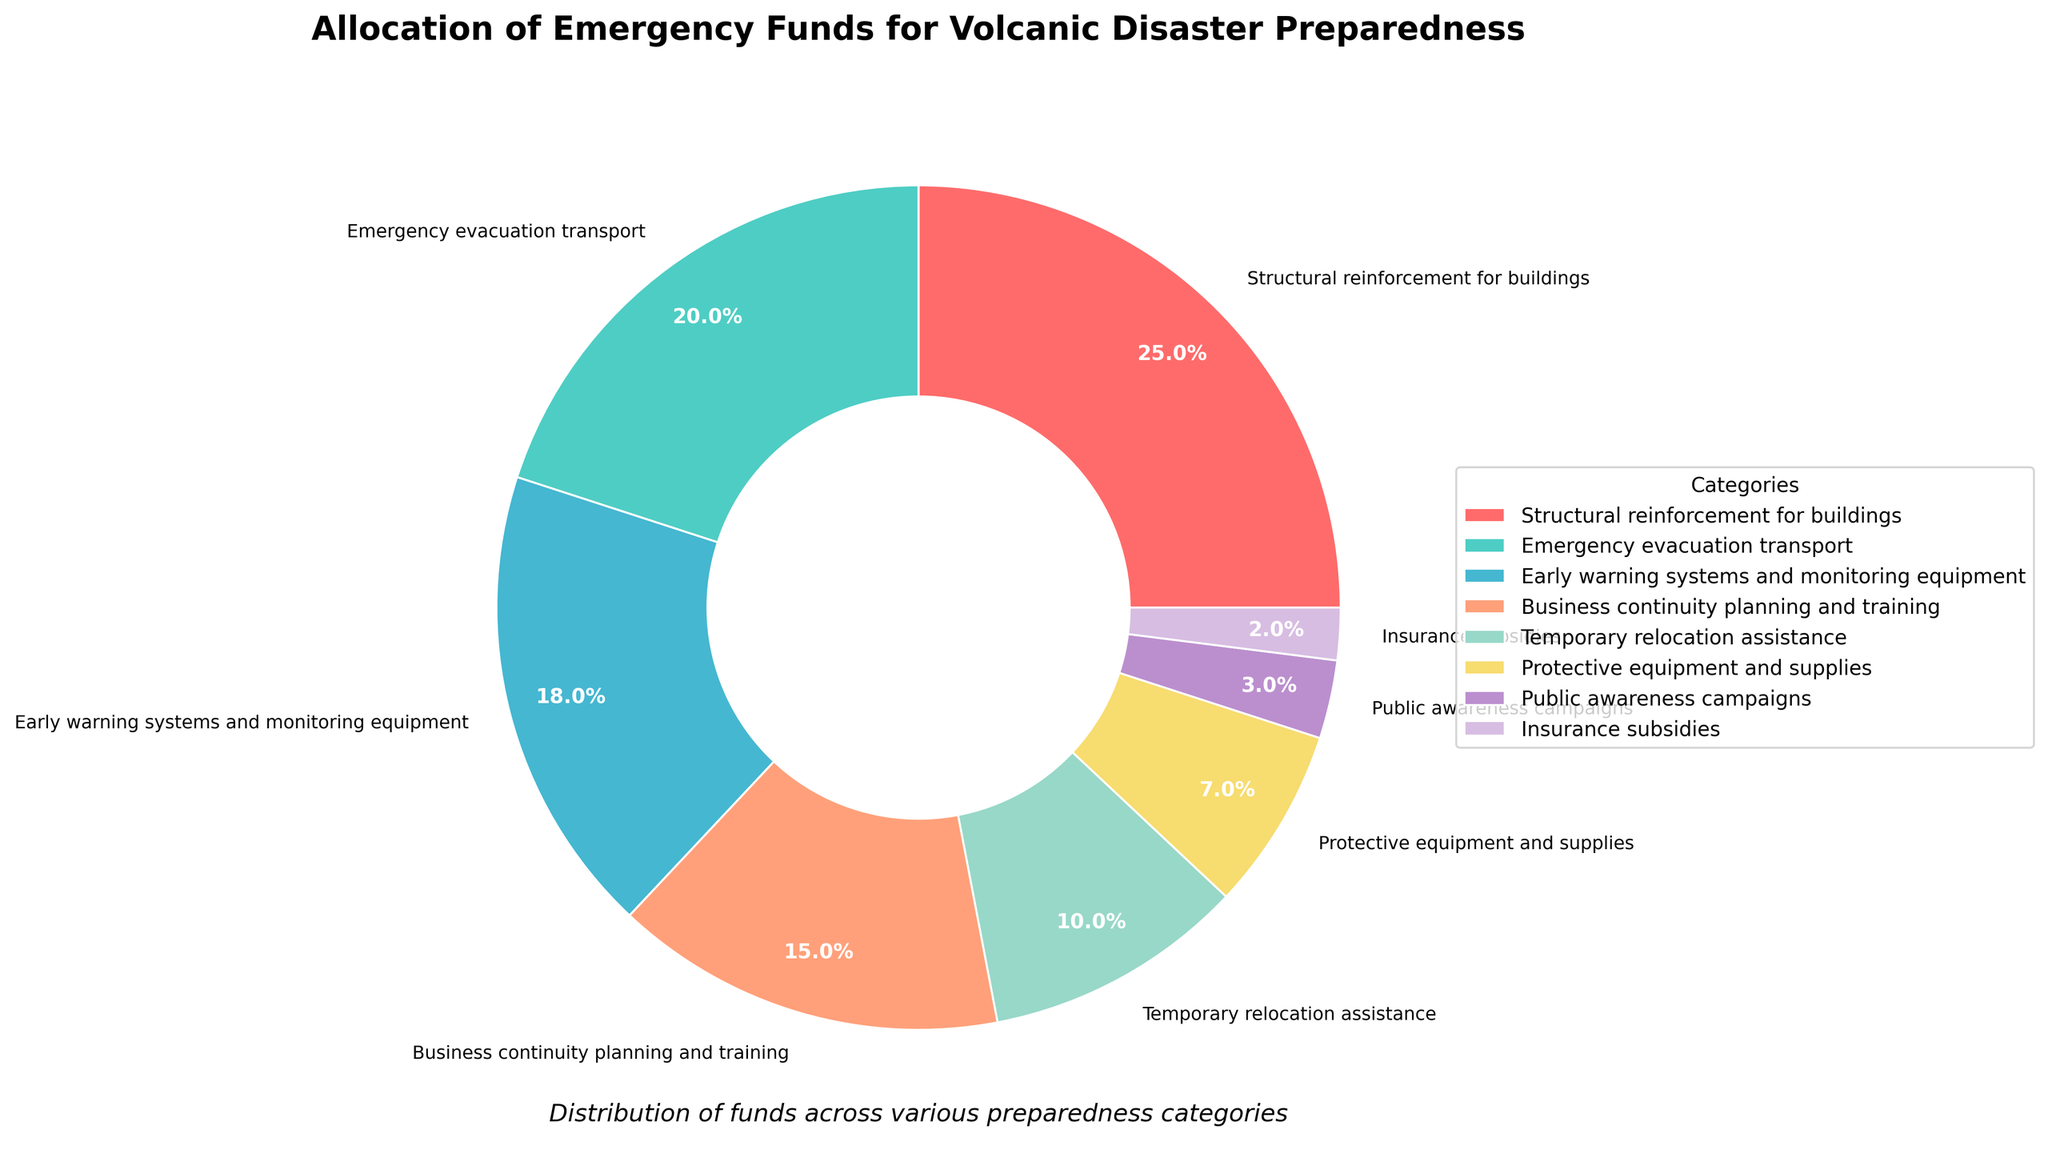What percentage of funds is allocated to early warning systems and monitoring equipment? Locate the segment labeled "Early warning systems and monitoring equipment." The percentage indicated is 18%.
Answer: 18% Which two categories together make up 35% of the total funds? "Structural reinforcement for buildings" is 25% and "Insurance subsidies" is 2%; however, the two closest categories that sum to 35% are "Business continuity planning and training" at 15% and "Emergency evacuation transport" at 20%. Thus, 15% + 20% = 35%.
Answer: Business continuity planning and training, Emergency evacuation transport Is more money allocated to structural reinforcement for buildings or business continuity planning and training? Compare the percentages for "Structural reinforcement for buildings" (25%) and "Business continuity planning and training" (15%). The former is higher.
Answer: Structural reinforcement for buildings What is the ratio of funds allocated to protective equipment and supplies compared to public awareness campaigns? The percentage for "Protective equipment and supplies" is 7% and for "Public awareness campaigns" is 3%. The ratio is 7:3.
Answer: 7:3 Find the combined percentage of funds allocated to emergency evacuation transport and temporary relocation assistance. "Emergency evacuation transport" is 20% and "Temporary relocation assistance" is 10%. Adding these gives 20% + 10% = 30%.
Answer: 30% Which category receives the smallest allocation of funds? Identify the segment with the smallest percentage. "Insurance subsidies" is the smallest at 2%.
Answer: Insurance subsidies How much more is allocated to structural reinforcement for buildings compared to protective equipment and supplies? The percentage for "Structural reinforcement for buildings" is 25% and "Protective equipment and supplies" is 7%. The difference is 25% - 7% = 18%.
Answer: 18% Which category has the closest percentage to that of early warning systems and monitoring equipment? The percentage for "Early warning systems and monitoring equipment" is 18%. Comparing with other categories, "Business continuity planning and training" at 15% is the closest.
Answer: Business continuity planning and training What is the total percentage of funds allocated to public awareness campaigns, insurance subsidies, and protective equipment and supplies? Add the percentages for "Public awareness campaigns" (3%), "Insurance subsidies" (2%), and "Protective equipment and supplies" (7%). This sums to 3% + 2% + 7% = 12%.
Answer: 12% Which category with a single-digit percentage allocation is the highest? Identify categories with single-digit percentages: "Temporary relocation assistance" (10%), "Protective equipment and supplies" (7%), "Public awareness campaigns" (3%), and "Insurance subsidies" (2%). The highest with a single-digit percentage is "Protective equipment and supplies" at 7%.
Answer: Protective equipment and supplies 